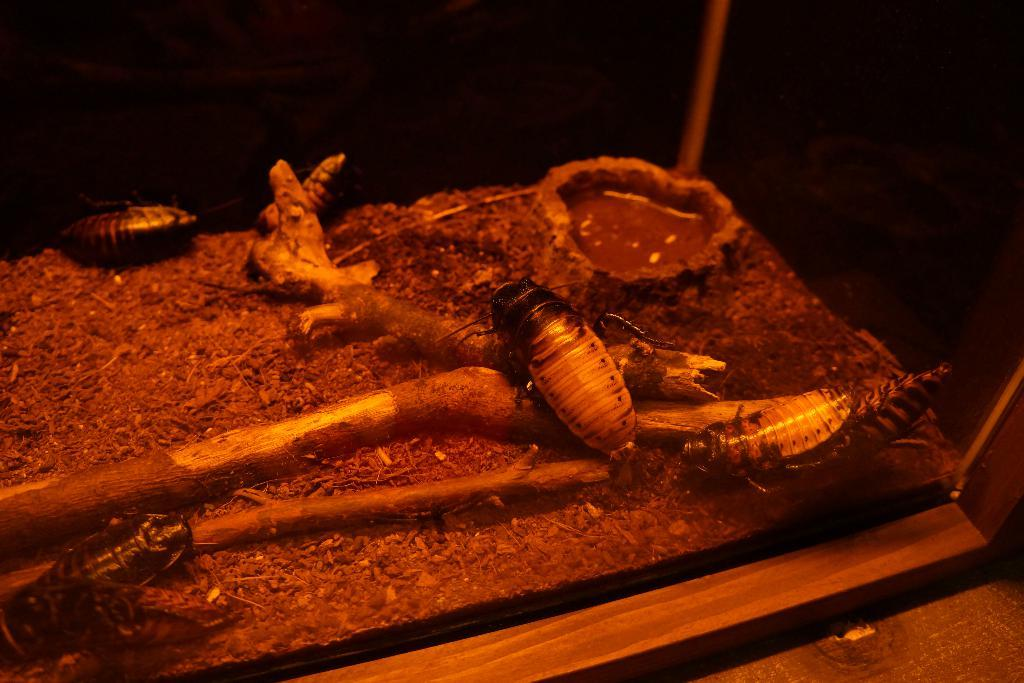What type of creatures can be seen in the image? There are many insects in the image. What object is present in the image that is not an insect? There is a wooden stick in the image. What can be used to hold or store the insects in the image? There is a container in the image. Can you tell me how many goldfish are swimming in the container in the image? There are no goldfish present in the image; it features insects and other objects. What type of cake is being baked in the oven in the image? There is no oven or cake present in the image. 